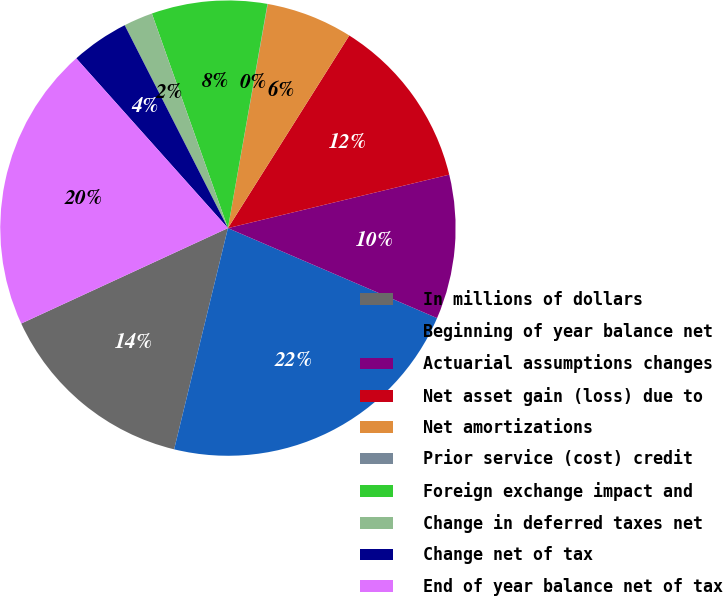Convert chart. <chart><loc_0><loc_0><loc_500><loc_500><pie_chart><fcel>In millions of dollars<fcel>Beginning of year balance net<fcel>Actuarial assumptions changes<fcel>Net asset gain (loss) due to<fcel>Net amortizations<fcel>Prior service (cost) credit<fcel>Foreign exchange impact and<fcel>Change in deferred taxes net<fcel>Change net of tax<fcel>End of year balance net of tax<nl><fcel>14.32%<fcel>22.33%<fcel>10.24%<fcel>12.28%<fcel>6.15%<fcel>0.02%<fcel>8.2%<fcel>2.07%<fcel>4.11%<fcel>20.28%<nl></chart> 